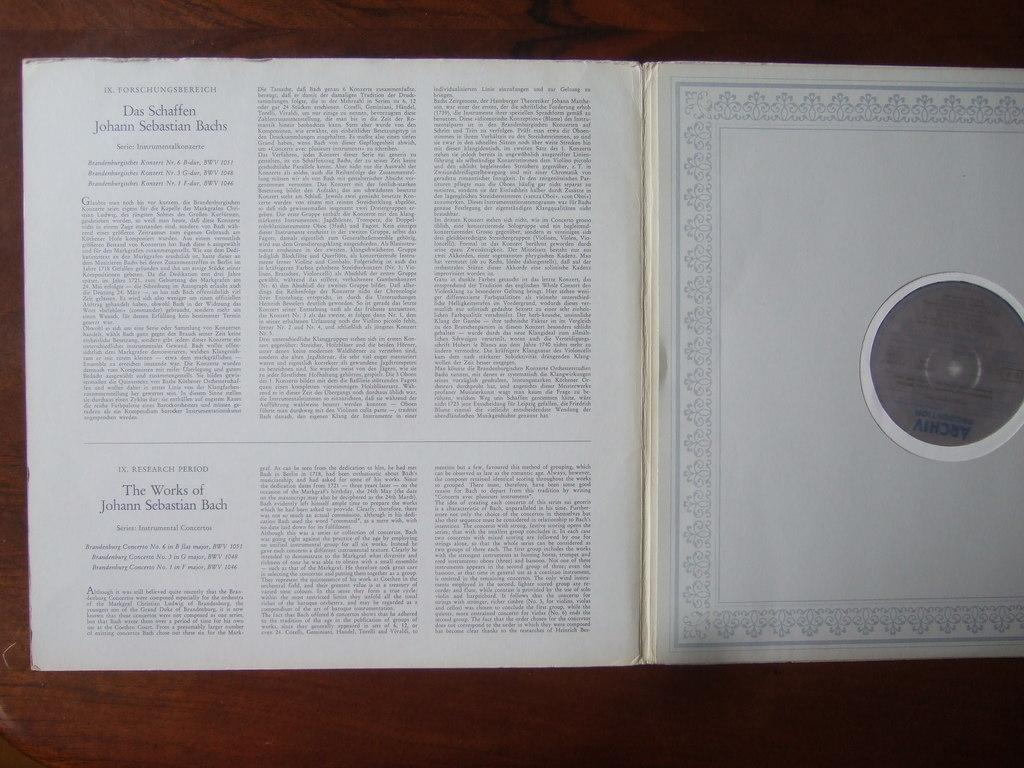<image>
Summarize the visual content of the image. A book that is about the musical works of Bach. 